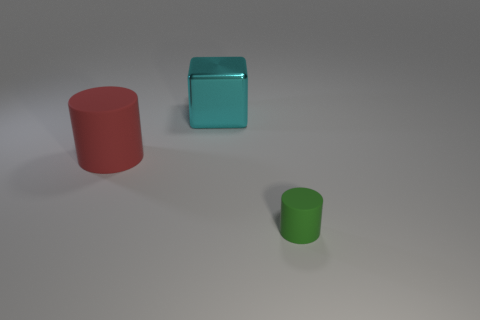Subtract all red cylinders. How many cylinders are left? 1 Add 1 green rubber cylinders. How many objects exist? 4 Subtract all cubes. How many objects are left? 2 Subtract 1 cubes. How many cubes are left? 0 Subtract all yellow cylinders. Subtract all green balls. How many cylinders are left? 2 Subtract all gray balls. How many red cylinders are left? 1 Subtract all tiny brown spheres. Subtract all red rubber objects. How many objects are left? 2 Add 2 cyan metal blocks. How many cyan metal blocks are left? 3 Add 1 small cyan spheres. How many small cyan spheres exist? 1 Subtract 0 yellow cylinders. How many objects are left? 3 